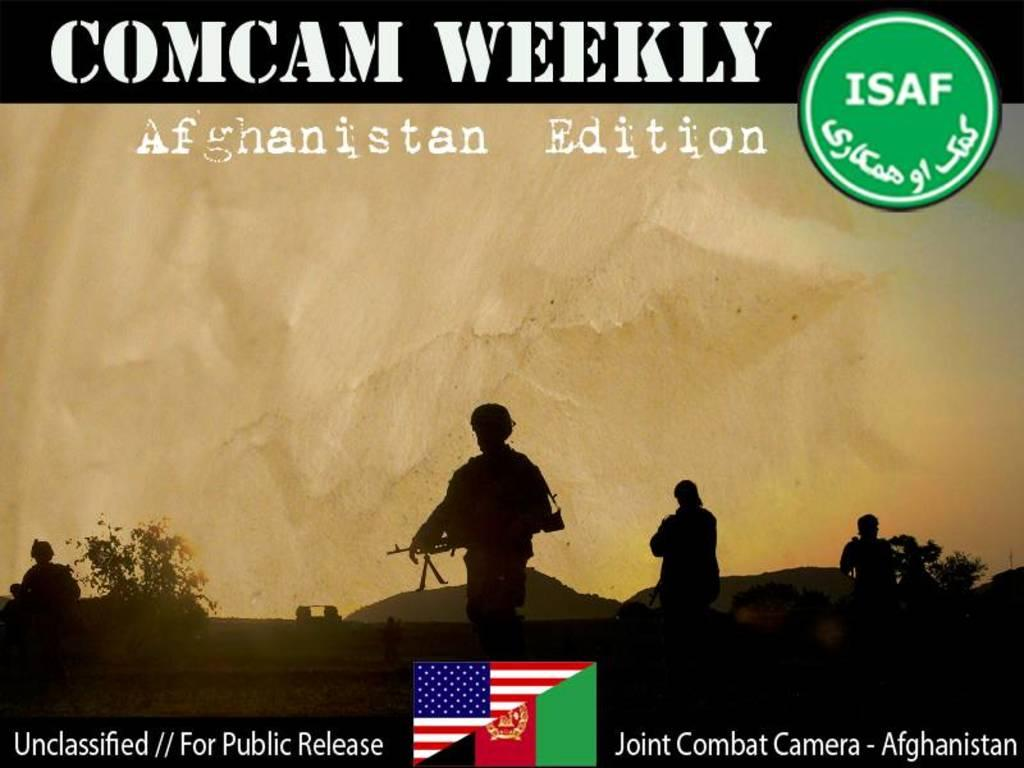<image>
Provide a brief description of the given image. A picture of soldiers on a poster that says COMCAM WEEKLY. 